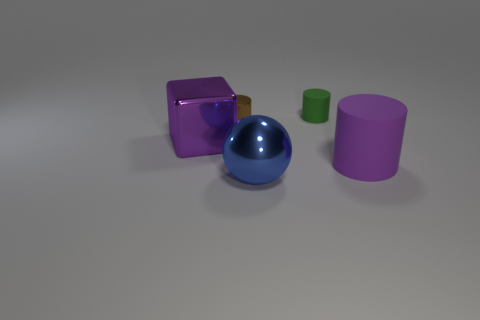Add 1 large red matte cylinders. How many objects exist? 6 Subtract all cylinders. How many objects are left? 2 Add 5 small gray metallic blocks. How many small gray metallic blocks exist? 5 Subtract 0 brown balls. How many objects are left? 5 Subtract all small red rubber cylinders. Subtract all large matte cylinders. How many objects are left? 4 Add 4 tiny green rubber things. How many tiny green rubber things are left? 5 